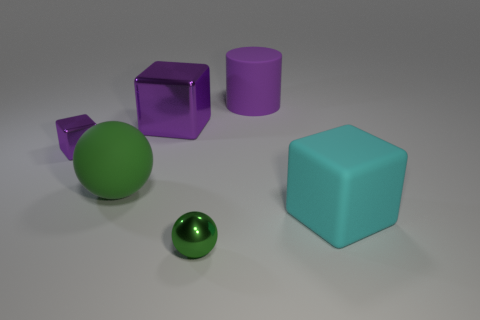Add 3 green objects. How many objects exist? 9 Subtract all purple blocks. How many blocks are left? 1 Subtract all purple blocks. How many blocks are left? 1 Subtract all large brown rubber balls. Subtract all cyan things. How many objects are left? 5 Add 5 matte cylinders. How many matte cylinders are left? 6 Add 1 big purple rubber cylinders. How many big purple rubber cylinders exist? 2 Subtract 0 brown cubes. How many objects are left? 6 Subtract all balls. How many objects are left? 4 Subtract 2 cubes. How many cubes are left? 1 Subtract all gray spheres. Subtract all blue cylinders. How many spheres are left? 2 